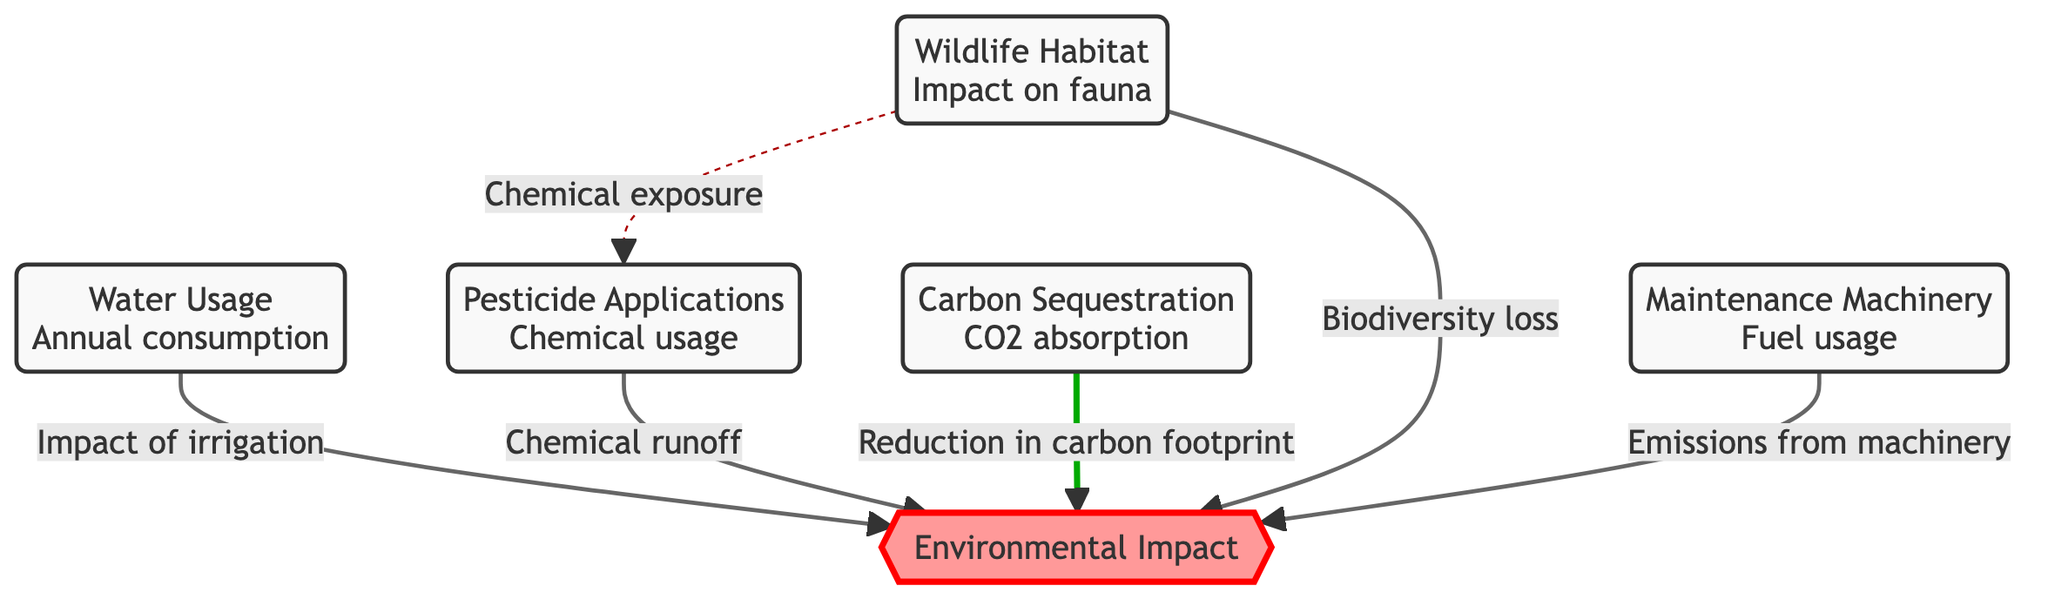What is the main aspect of the diagram? The diagram focuses on the environmental impact of golf courses and illustrates the relationships between various factors, such as water usage, pesticide applications, and carbon sequestration.
Answer: Environmental impact How many factors contribute to the environmental impact in the diagram? There are five factors connected to the environmental impact: water usage, pesticide applications, carbon sequestration, wildlife habitat, and maintenance machinery.
Answer: Five What is the relationship between water usage and environmental impact? The diagram indicates that water usage directly impacts the environmental impact through irrigation.
Answer: Impact of irrigation Which factor has a relationship with both wildlife habitat and pesticide applications? The wildlife habitat is linked to pesticide applications through chemical exposure, indicating that pesticides affect the fauna and biodiversity in the area.
Answer: Chemical exposure What kind of impact does carbon sequestration have according to the diagram? Carbon sequestration contributes to a reduction in carbon footprint, showing its positive aspect in the context of environmental impact.
Answer: Reduction in carbon footprint What is one negative aspect of maintenance machinery highlighted in the diagram? The diagram shows that maintenance machinery results in emissions, which is a negative contribution to the environmental impact.
Answer: Emissions from machinery What does the dotted line indicate between wildlife habitat and pesticide applications? The dotted line represents a less direct relationship, specifically the concern of chemical exposure affecting wildlife due to pesticide applications.
Answer: Chemical exposure What type of usage is indicated by the label under "water usage"? The label under water usage indicates annual consumption, specifying the nature of the water usage being discussed.
Answer: Annual consumption How does pesticide applications affect the environmental impact according to the flow? Pesticide applications contribute to environmental impact through chemical runoff, suggesting that the chemicals are carried away, potentially harming surrounding ecosystems.
Answer: Chemical runoff 